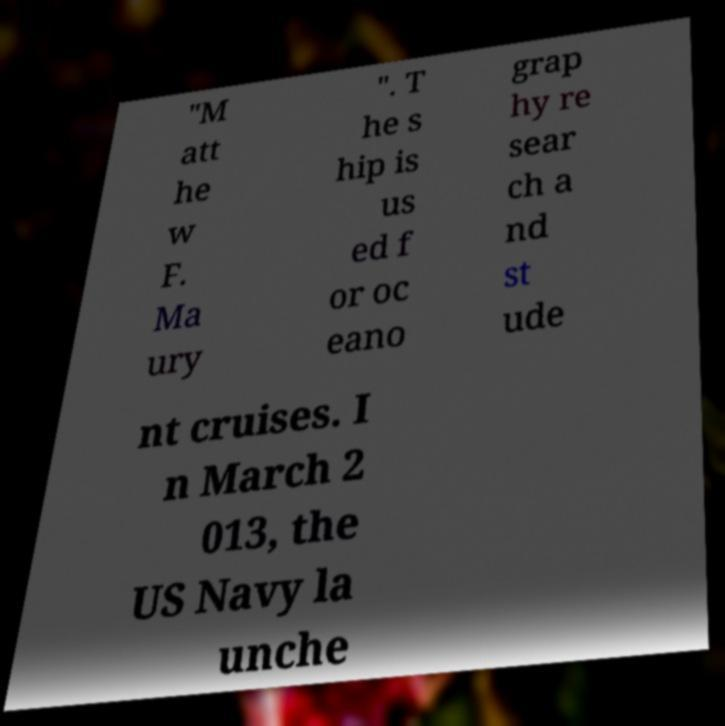I need the written content from this picture converted into text. Can you do that? "M att he w F. Ma ury ". T he s hip is us ed f or oc eano grap hy re sear ch a nd st ude nt cruises. I n March 2 013, the US Navy la unche 